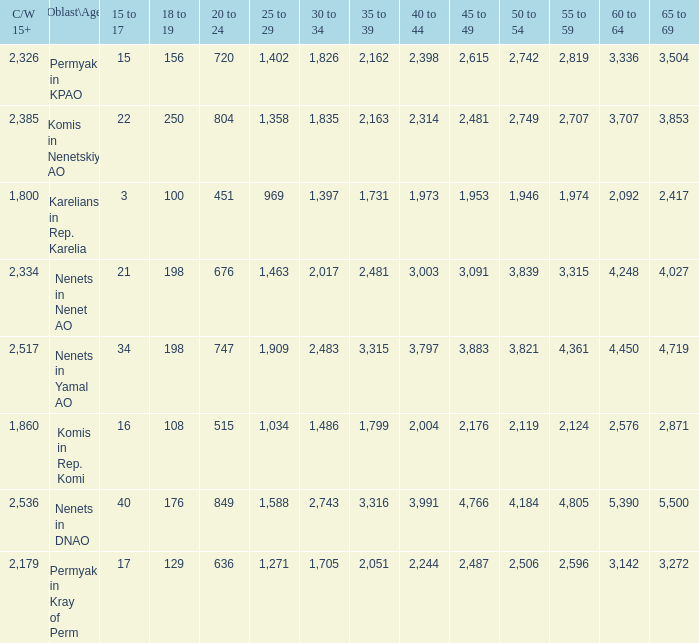With a 35 to 39 greater than 3,315 what is the 45 to 49? 4766.0. 